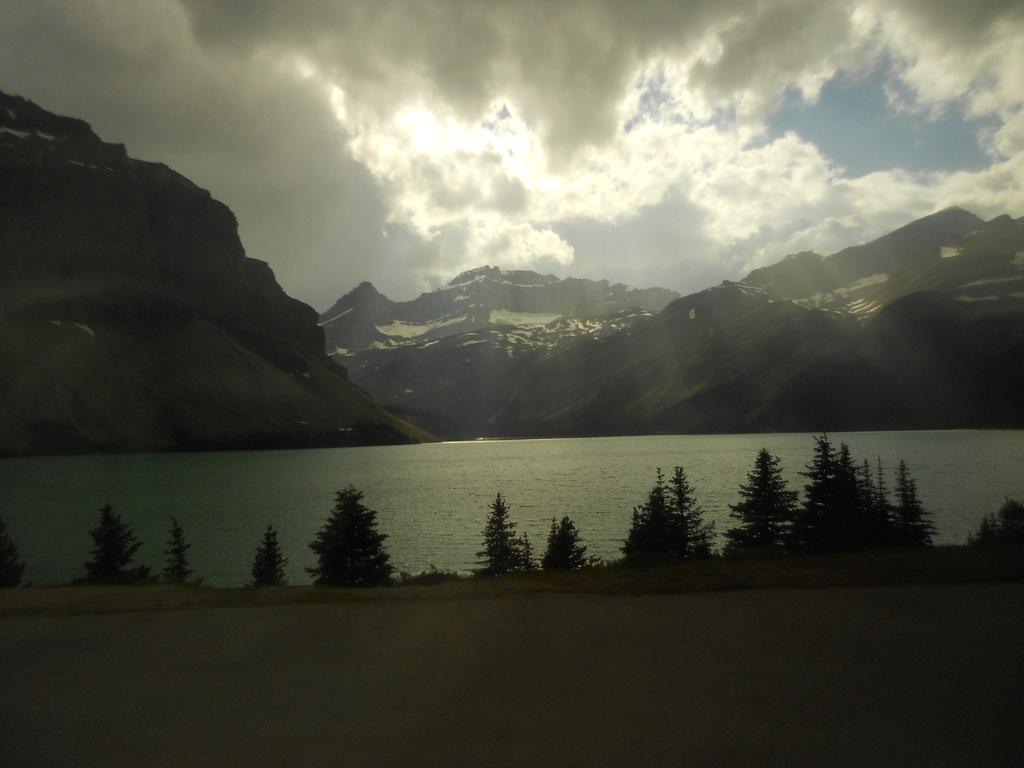What type of landscape can be seen in the image? There are hills in the image. What natural element is visible in the image? There is water visible in the image. What type of vegetation is present in the image? There are trees in the image. How would you describe the sky in the image? The sky is blue and cloudy in the image. What type of bell can be heard ringing in the image? There is no bell present in the image, and therefore no sound can be heard. What health benefits can be gained from the trees in the image? The image does not provide information about the health benefits of the trees; it only shows their presence. 